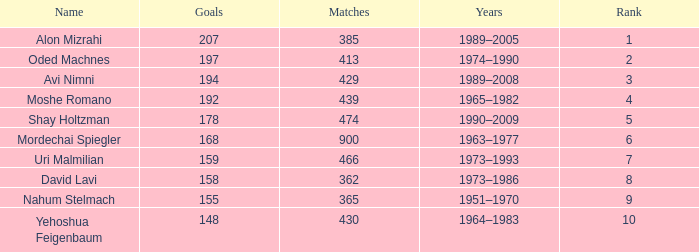What is the Rank of the player with 362 Matches? 8.0. 